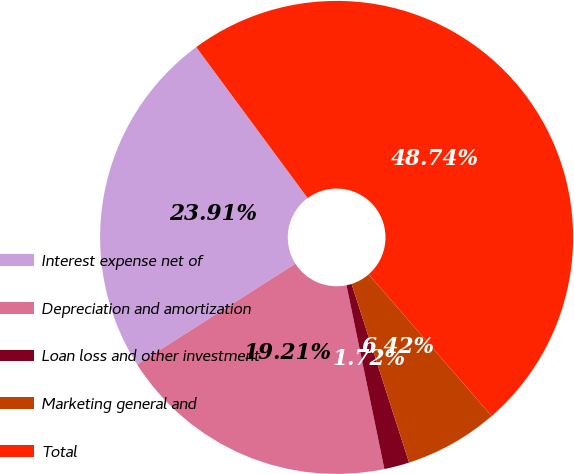Convert chart. <chart><loc_0><loc_0><loc_500><loc_500><pie_chart><fcel>Interest expense net of<fcel>Depreciation and amortization<fcel>Loan loss and other investment<fcel>Marketing general and<fcel>Total<nl><fcel>23.91%<fcel>19.21%<fcel>1.72%<fcel>6.42%<fcel>48.74%<nl></chart> 